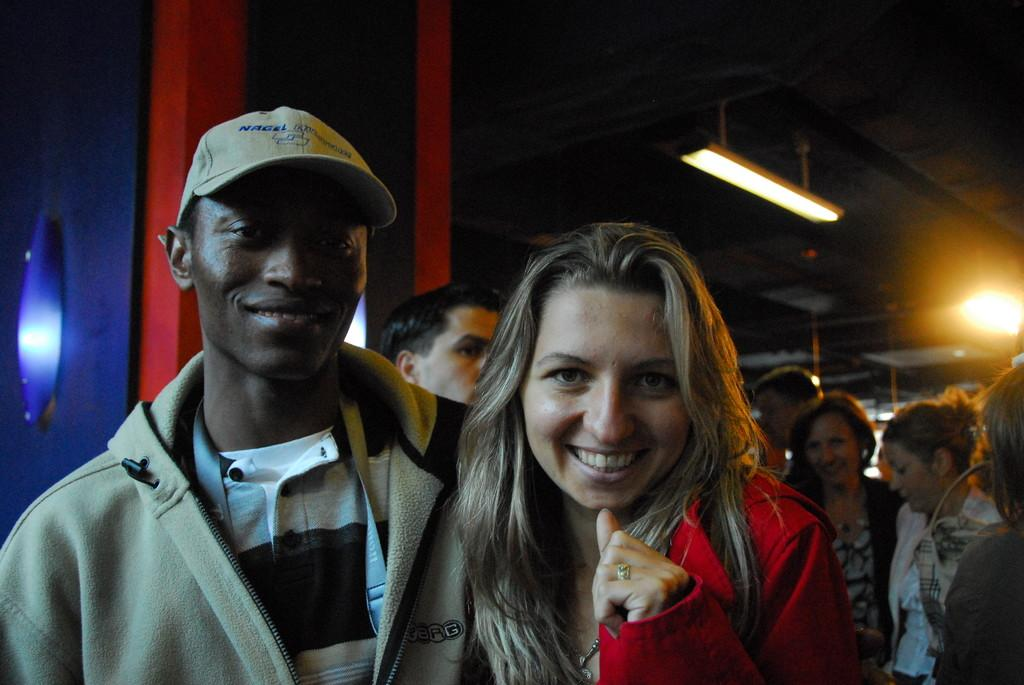What are the people in the front of the image doing? The persons in the front of the image are standing and smiling. Can you describe the people in the background of the image? There are persons in the background of the image, but no specific details about them are provided. What can be seen in the background of the image? There are lights and objects with blue and red colors visible in the background. What type of crack is visible in the image? There is no crack present in the image. How many birds can be seen flying in the image? There are no birds visible in the image. 